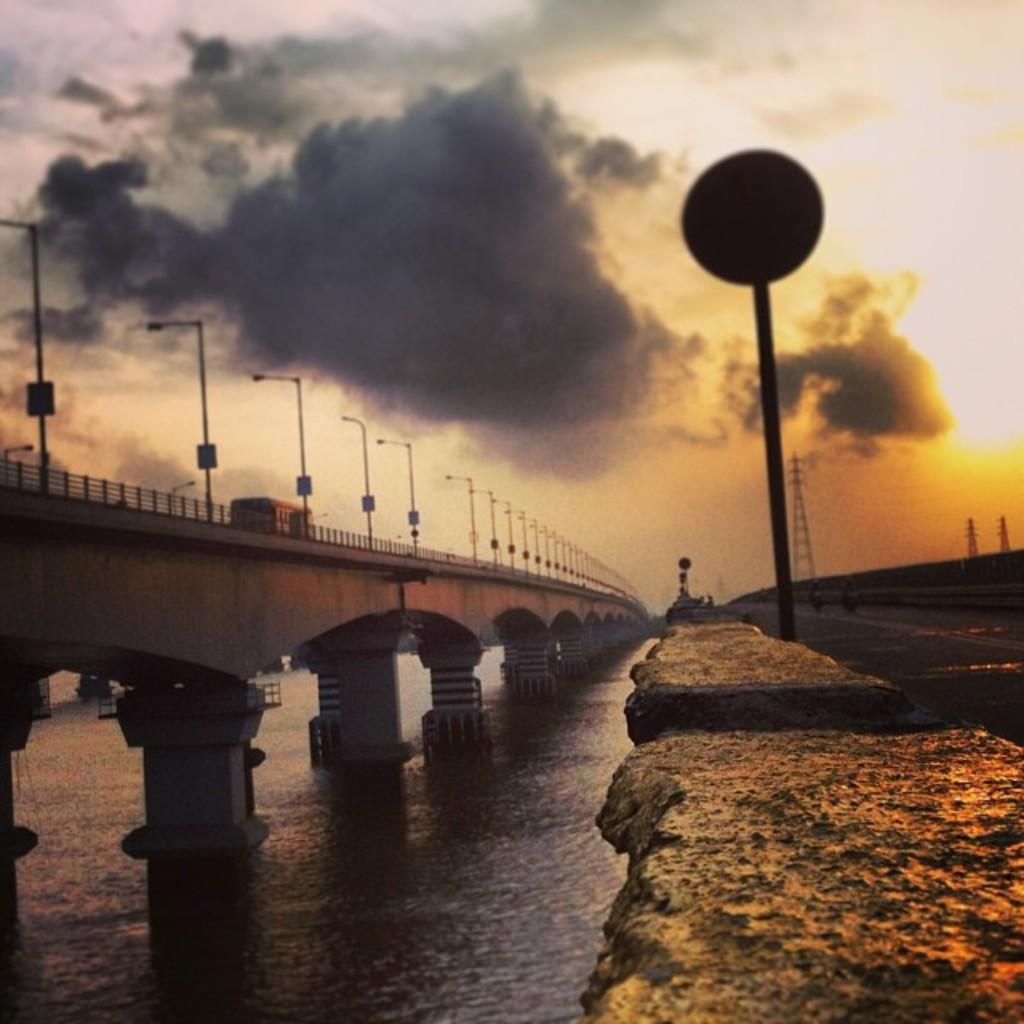Describe this image in one or two sentences. In this image, we can see the bridge with an object. We can see some poles. We can see the ground with some objects. We can also see some water with a few objects. We can see some towers. 